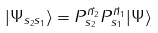Convert formula to latex. <formula><loc_0><loc_0><loc_500><loc_500>| \Psi _ { s _ { 2 } s _ { 1 } } \rangle = P ^ { \vec { n } _ { 2 } } _ { s _ { 2 } } P ^ { \vec { n } _ { 1 } } _ { s _ { 1 } } | \Psi \rangle</formula> 